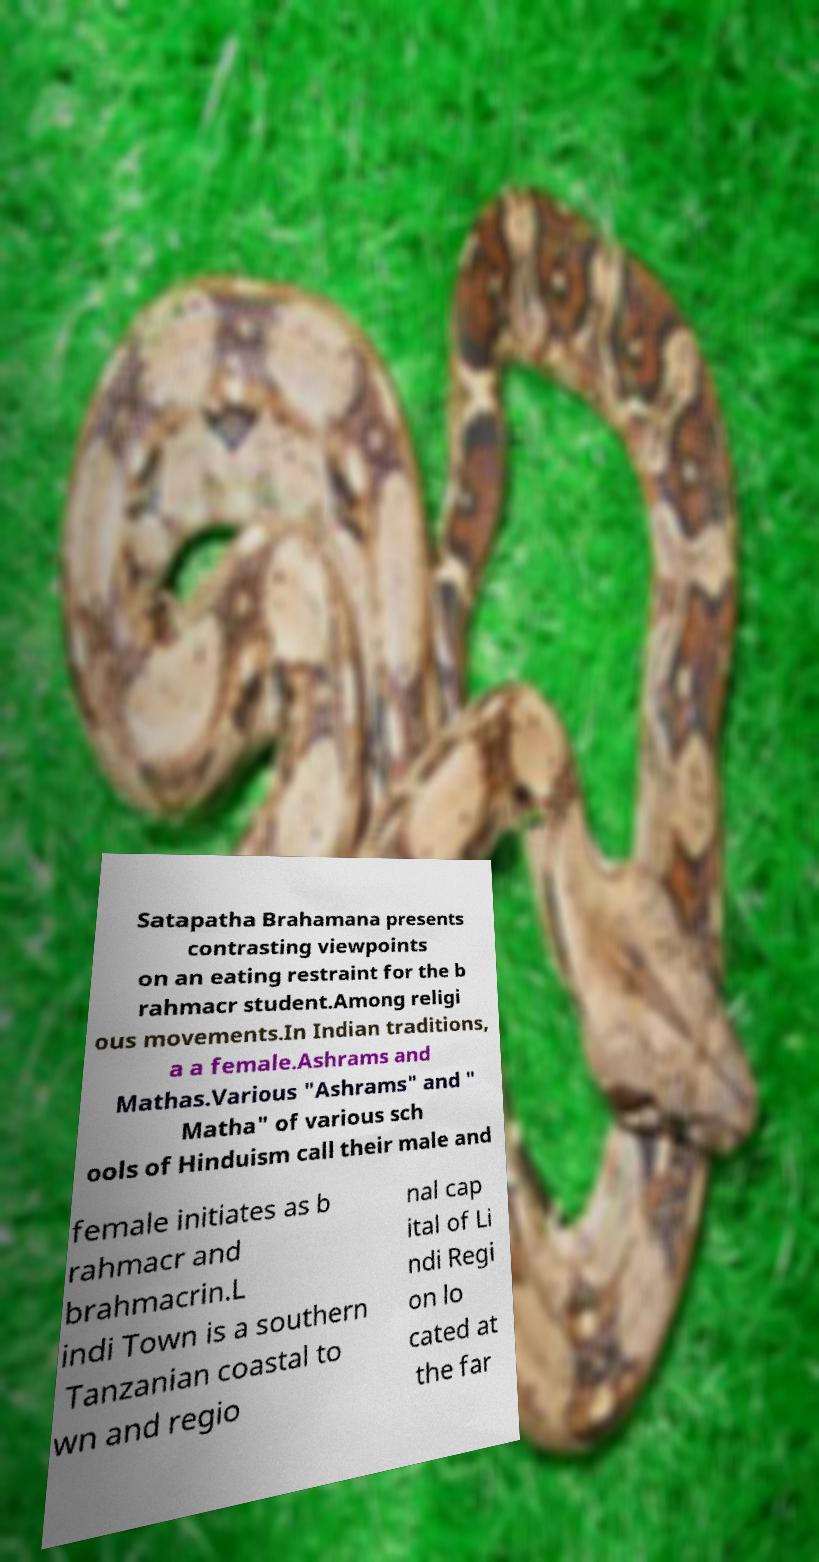Please read and relay the text visible in this image. What does it say? Satapatha Brahamana presents contrasting viewpoints on an eating restraint for the b rahmacr student.Among religi ous movements.In Indian traditions, a a female.Ashrams and Mathas.Various "Ashrams" and " Matha" of various sch ools of Hinduism call their male and female initiates as b rahmacr and brahmacrin.L indi Town is a southern Tanzanian coastal to wn and regio nal cap ital of Li ndi Regi on lo cated at the far 